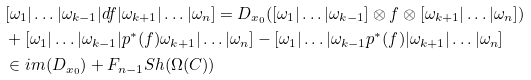<formula> <loc_0><loc_0><loc_500><loc_500>& [ \omega _ { 1 } | \dots | \omega _ { k - 1 } | d f | \omega _ { k + 1 } | \dots | \omega _ { n } ] = D _ { x _ { 0 } } ( [ \omega _ { 1 } | \dots | \omega _ { k - 1 } ] \otimes f \otimes [ \omega _ { k + 1 } | \dots | \omega _ { n } ] ) \\ & + [ \omega _ { 1 } | \dots | \omega _ { k - 1 } | p ^ { * } ( f ) \omega _ { k + 1 } | \dots | \omega _ { n } ] - [ \omega _ { 1 } | \dots | \omega _ { k - 1 } p ^ { * } ( f ) | \omega _ { k + 1 } | \dots | \omega _ { n } ] \\ & \in i m ( D _ { x _ { 0 } } ) + F _ { n - 1 } S h ( \Omega ( C ) )</formula> 